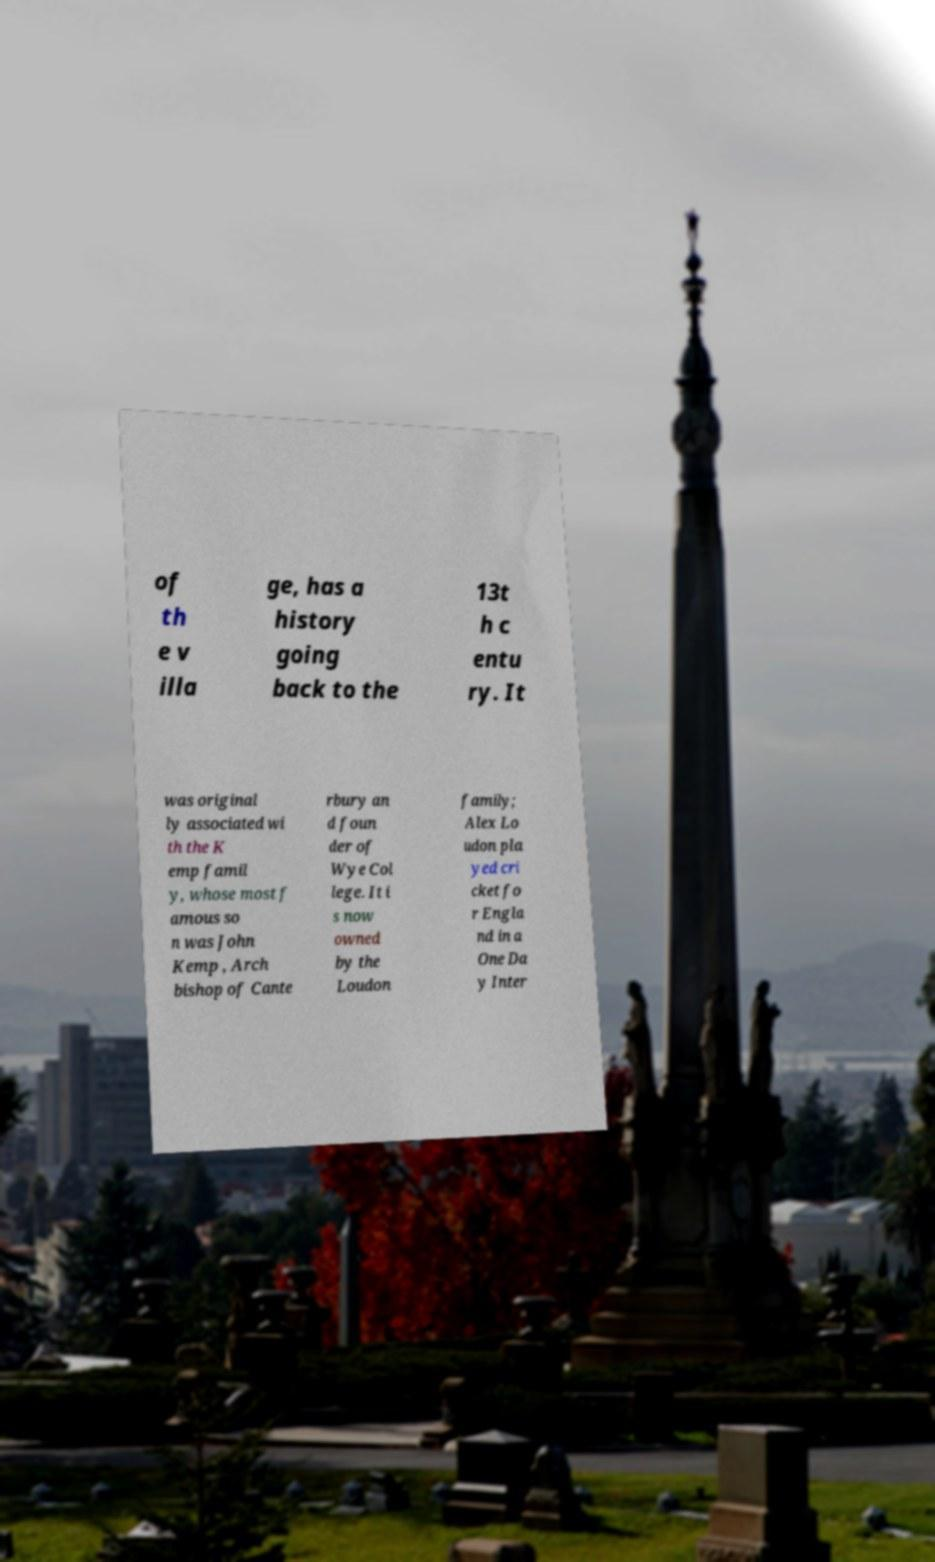Can you read and provide the text displayed in the image?This photo seems to have some interesting text. Can you extract and type it out for me? of th e v illa ge, has a history going back to the 13t h c entu ry. It was original ly associated wi th the K emp famil y, whose most f amous so n was John Kemp , Arch bishop of Cante rbury an d foun der of Wye Col lege. It i s now owned by the Loudon family; Alex Lo udon pla yed cri cket fo r Engla nd in a One Da y Inter 